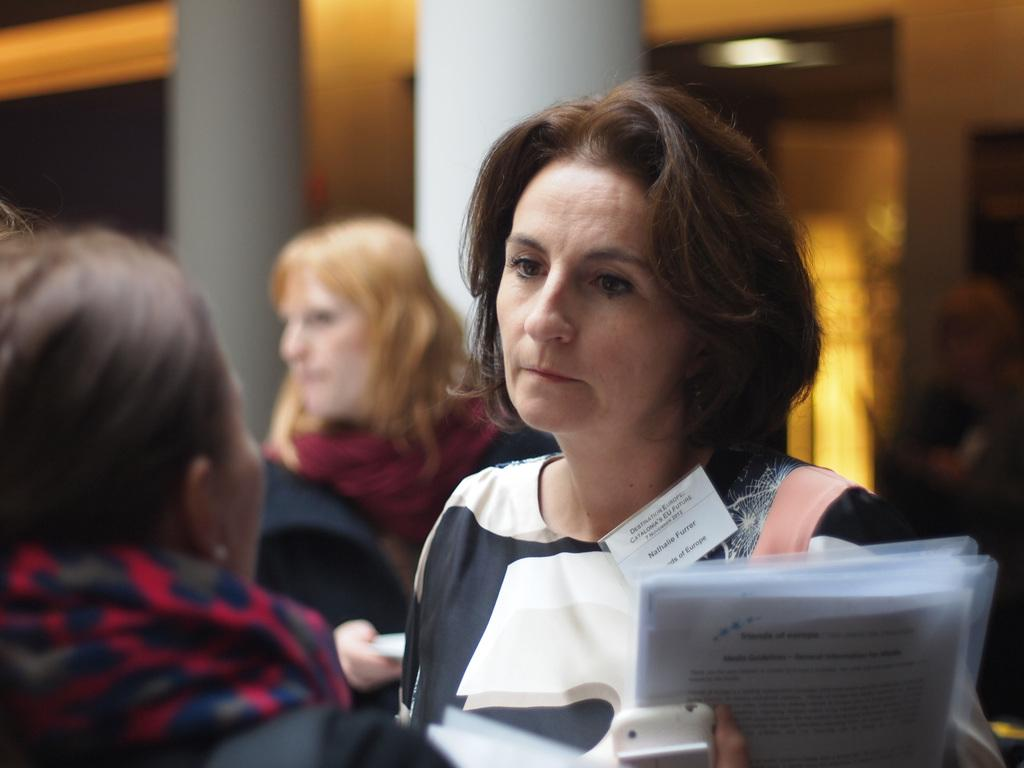What is the general emotion displayed by the women in the image? The women appear to be sad in the image. What is the woman in front holding in her hands? The woman in front is holding a file and a cellphone. What can be seen in the background of the image? There are pillars in the background of the image. What type of van can be seen driving through the air in the image? There is no van or any indication of air travel present in the image. 